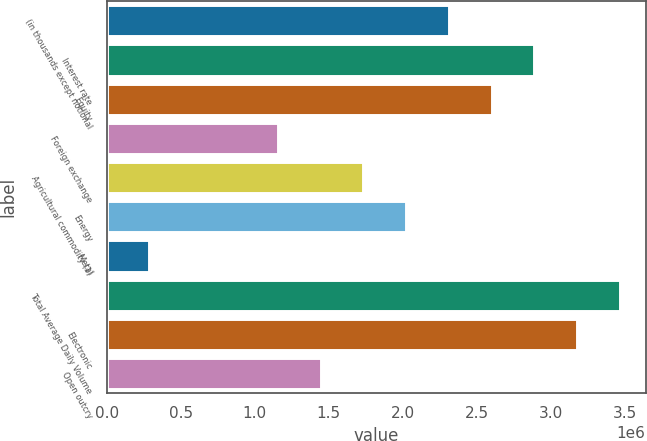<chart> <loc_0><loc_0><loc_500><loc_500><bar_chart><fcel>(in thousands except notional<fcel>Interest rate<fcel>Equity<fcel>Foreign exchange<fcel>Agricultural commodity (1)<fcel>Energy<fcel>Metal<fcel>Total Average Daily Volume<fcel>Electronic<fcel>Open outcry<nl><fcel>2.31207e+06<fcel>2.89004e+06<fcel>2.60105e+06<fcel>1.15615e+06<fcel>1.73411e+06<fcel>2.02309e+06<fcel>289202<fcel>3.468e+06<fcel>3.17902e+06<fcel>1.44513e+06<nl></chart> 